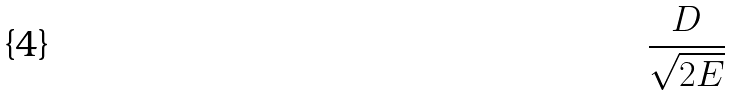Convert formula to latex. <formula><loc_0><loc_0><loc_500><loc_500>\frac { D } { \sqrt { 2 E } }</formula> 